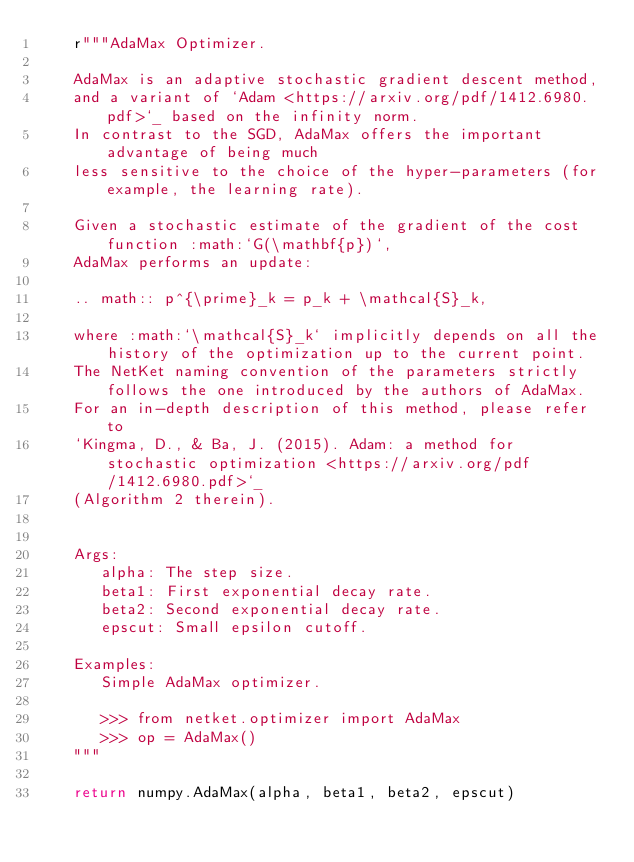<code> <loc_0><loc_0><loc_500><loc_500><_Python_>    r"""AdaMax Optimizer.

    AdaMax is an adaptive stochastic gradient descent method,
    and a variant of `Adam <https://arxiv.org/pdf/1412.6980.pdf>`_ based on the infinity norm.
    In contrast to the SGD, AdaMax offers the important advantage of being much
    less sensitive to the choice of the hyper-parameters (for example, the learning rate).

    Given a stochastic estimate of the gradient of the cost function :math:`G(\mathbf{p})`,
    AdaMax performs an update:

    .. math:: p^{\prime}_k = p_k + \mathcal{S}_k,

    where :math:`\mathcal{S}_k` implicitly depends on all the history of the optimization up to the current point.
    The NetKet naming convention of the parameters strictly follows the one introduced by the authors of AdaMax.
    For an in-depth description of this method, please refer to
    `Kingma, D., & Ba, J. (2015). Adam: a method for stochastic optimization <https://arxiv.org/pdf/1412.6980.pdf>`_
    (Algorithm 2 therein).


    Args:
       alpha: The step size.
       beta1: First exponential decay rate.
       beta2: Second exponential decay rate.
       epscut: Small epsilon cutoff.

    Examples:
       Simple AdaMax optimizer.

       >>> from netket.optimizer import AdaMax
       >>> op = AdaMax()
    """

    return numpy.AdaMax(alpha, beta1, beta2, epscut)
</code> 